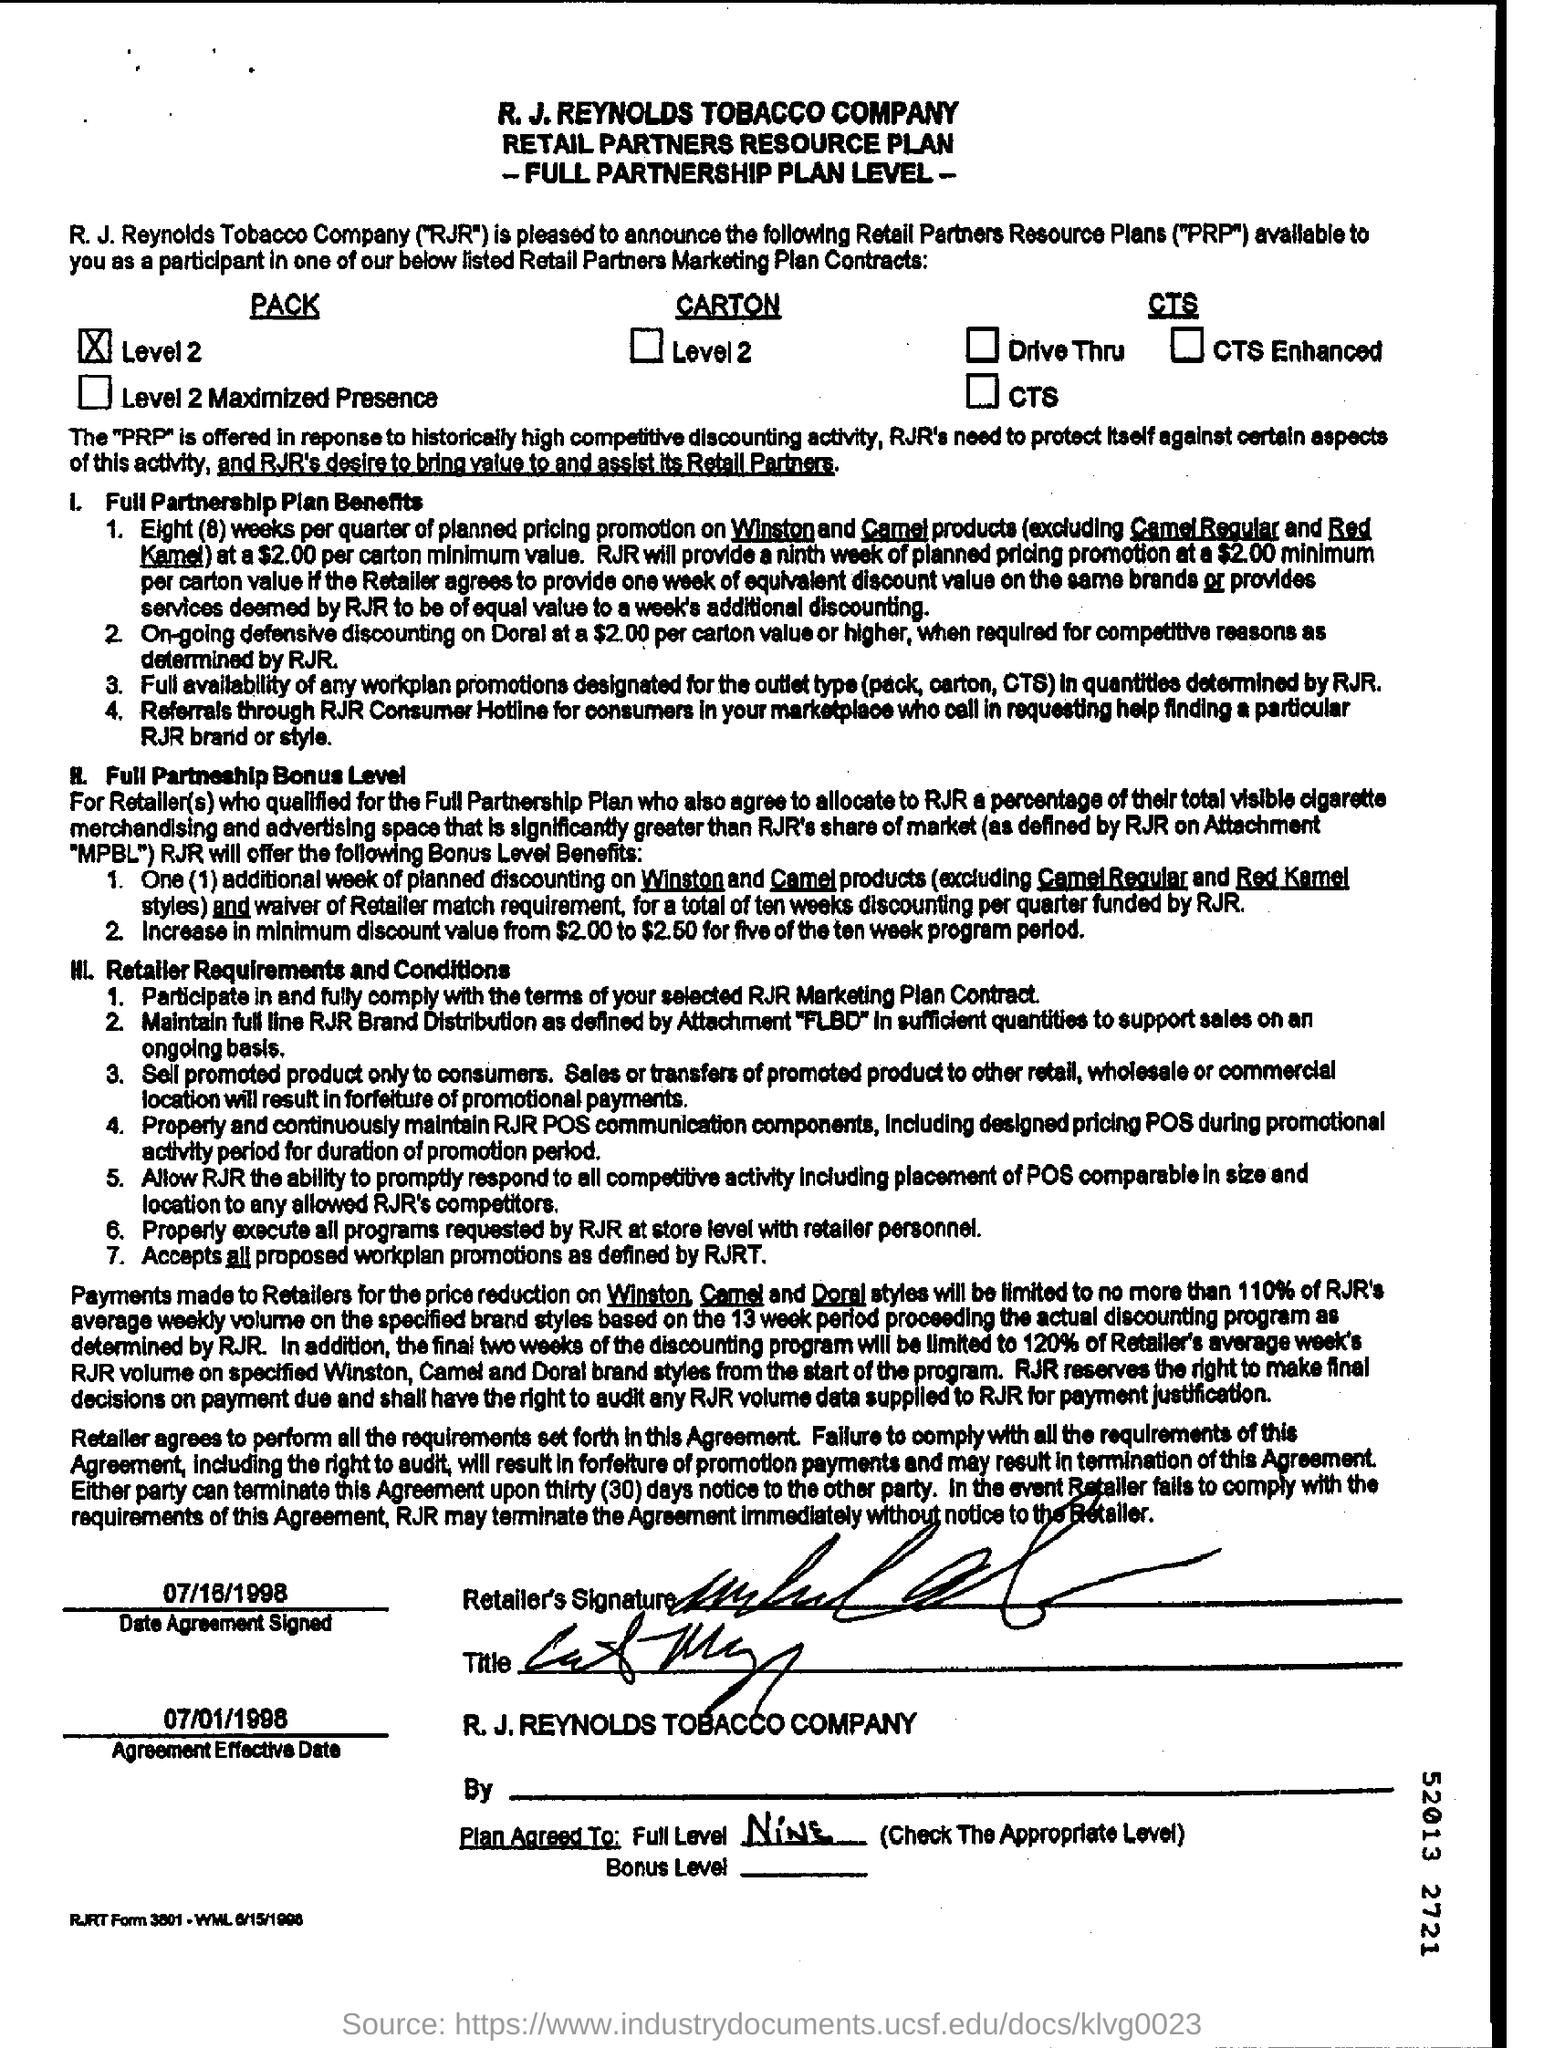What is the first title in the document?
Ensure brevity in your answer.  R.J. Reynolds Tobacco Company. What is the second title in this document?
Provide a succinct answer. Retail Partners Resource Plan. 